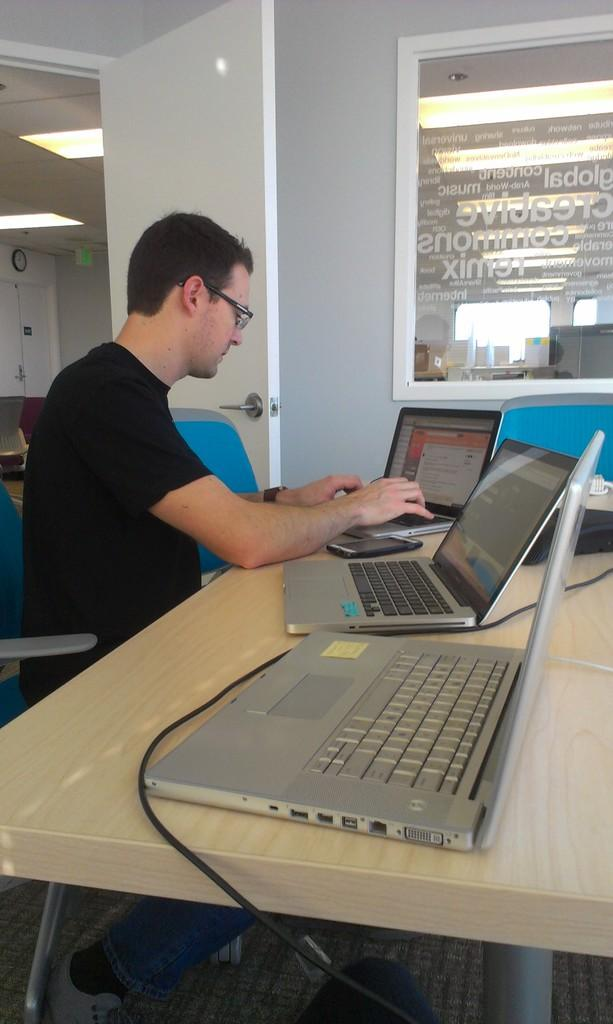What is the man doing in the image? The man is sitting on a chair in the image. What objects are on the table in front of the man? There are laptops on a table in front of the man. What is located beside the man? There is a door and a window beside the man. What color is the art displayed on the wall behind the man? There is no art displayed on the wall behind the man in the image. 